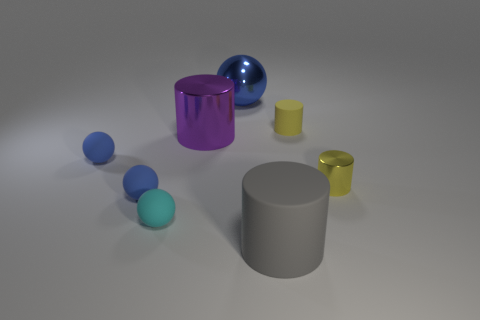Which colors are predominant in this composition, and how do they affect the overall mood? In this composition, cool tones like blue and purple are predominant, alongside neutral grey. These colors contribute to a calm and somewhat understated mood. The pops of yellow add a subtle vibrancy to the scene, but overall, the color palette is quite restrained, imparting a minimalist and modern aesthetic to the image. 